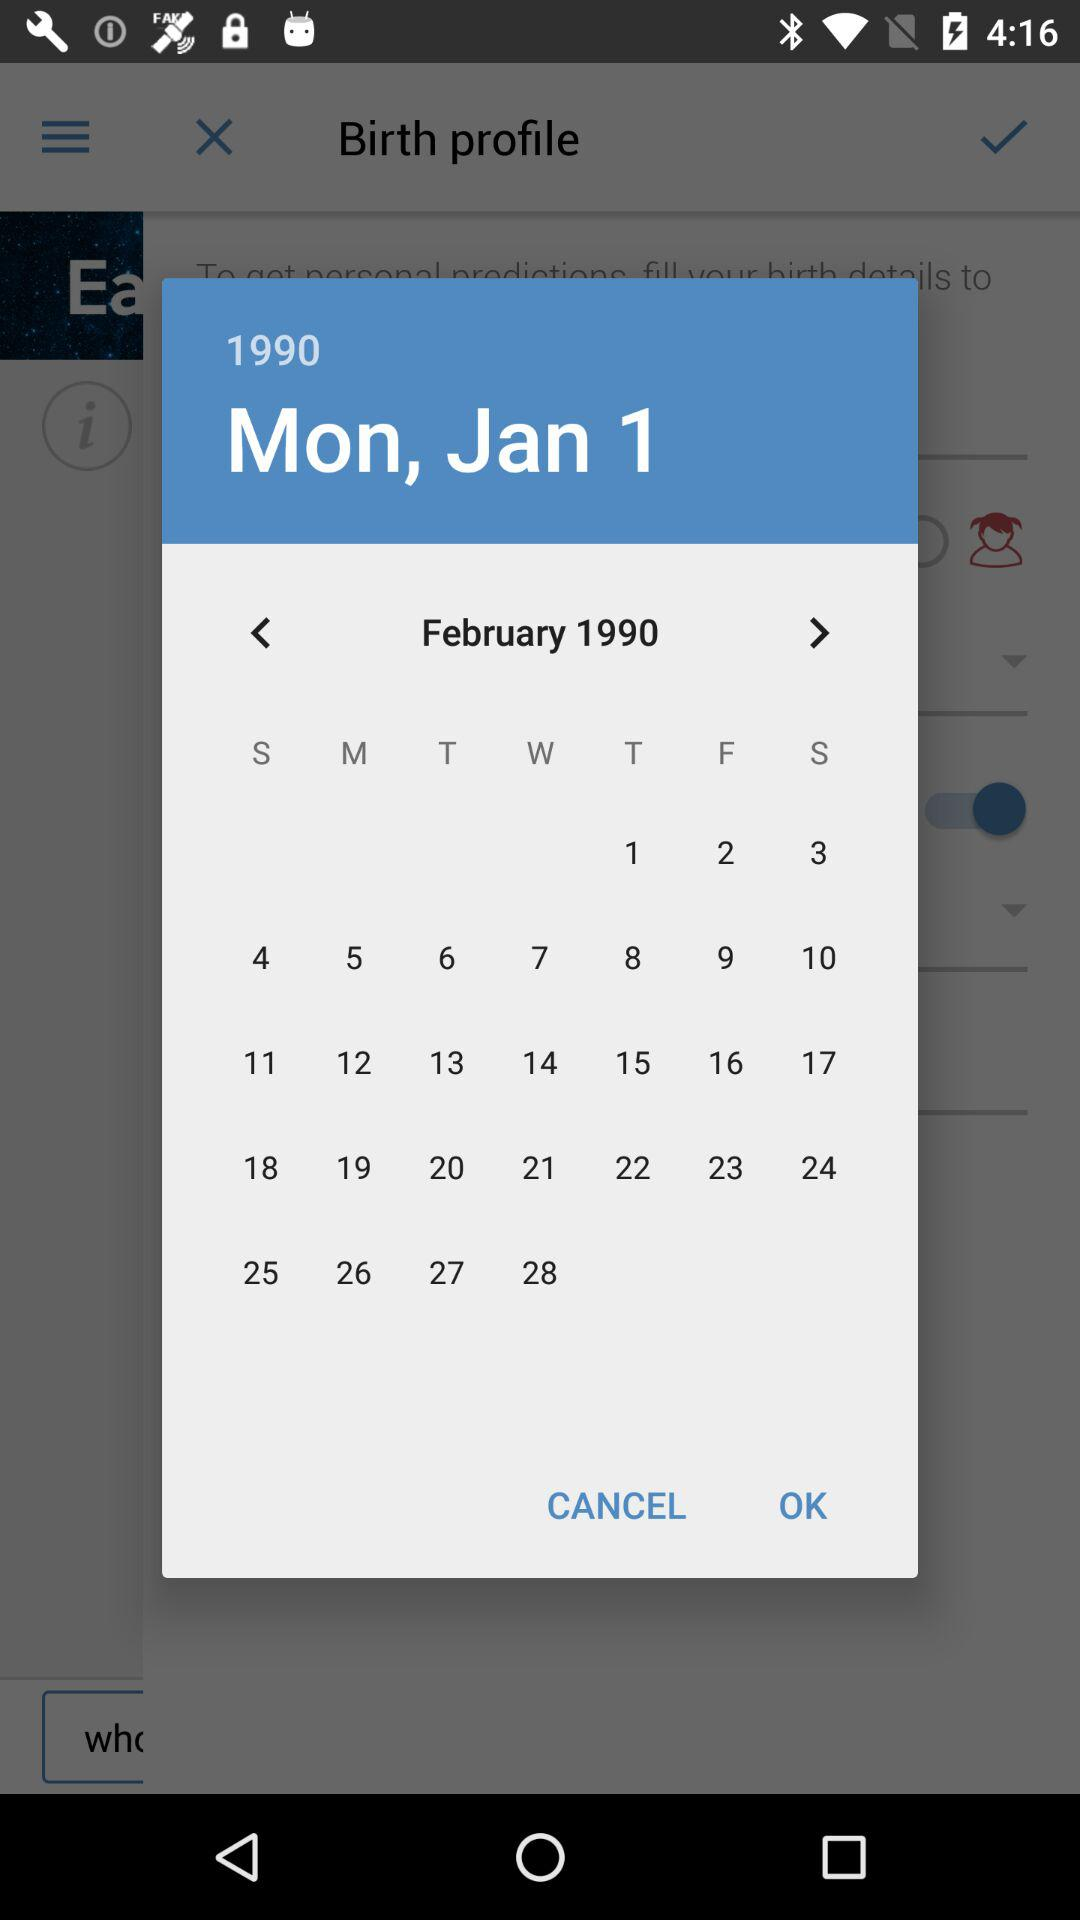What day falls on February 23rd, 1990? The day is Friday. 